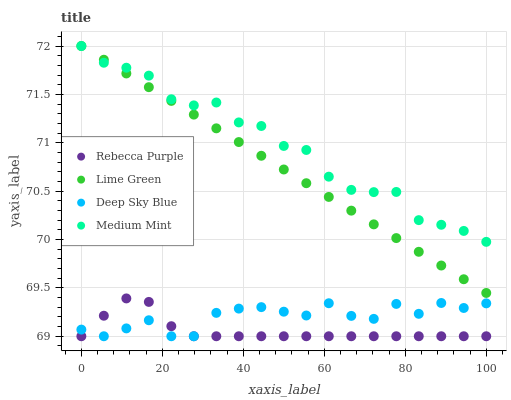Does Rebecca Purple have the minimum area under the curve?
Answer yes or no. Yes. Does Medium Mint have the maximum area under the curve?
Answer yes or no. Yes. Does Lime Green have the minimum area under the curve?
Answer yes or no. No. Does Lime Green have the maximum area under the curve?
Answer yes or no. No. Is Lime Green the smoothest?
Answer yes or no. Yes. Is Deep Sky Blue the roughest?
Answer yes or no. Yes. Is Rebecca Purple the smoothest?
Answer yes or no. No. Is Rebecca Purple the roughest?
Answer yes or no. No. Does Rebecca Purple have the lowest value?
Answer yes or no. Yes. Does Lime Green have the lowest value?
Answer yes or no. No. Does Lime Green have the highest value?
Answer yes or no. Yes. Does Rebecca Purple have the highest value?
Answer yes or no. No. Is Rebecca Purple less than Lime Green?
Answer yes or no. Yes. Is Medium Mint greater than Deep Sky Blue?
Answer yes or no. Yes. Does Medium Mint intersect Lime Green?
Answer yes or no. Yes. Is Medium Mint less than Lime Green?
Answer yes or no. No. Is Medium Mint greater than Lime Green?
Answer yes or no. No. Does Rebecca Purple intersect Lime Green?
Answer yes or no. No. 